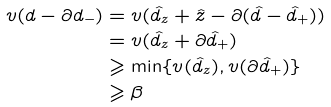<formula> <loc_0><loc_0><loc_500><loc_500>v ( d - \partial d _ { - } ) & = v ( \hat { d } _ { z } + \hat { z } - \partial ( \hat { d } - \hat { d } _ { + } ) ) \\ & = v ( \hat { d } _ { z } + \partial \hat { d } _ { + } ) \\ & \geqslant \min \{ v ( \hat { d } _ { z } ) , v ( \partial \hat { d } _ { + } ) \} \\ & \geqslant \beta</formula> 